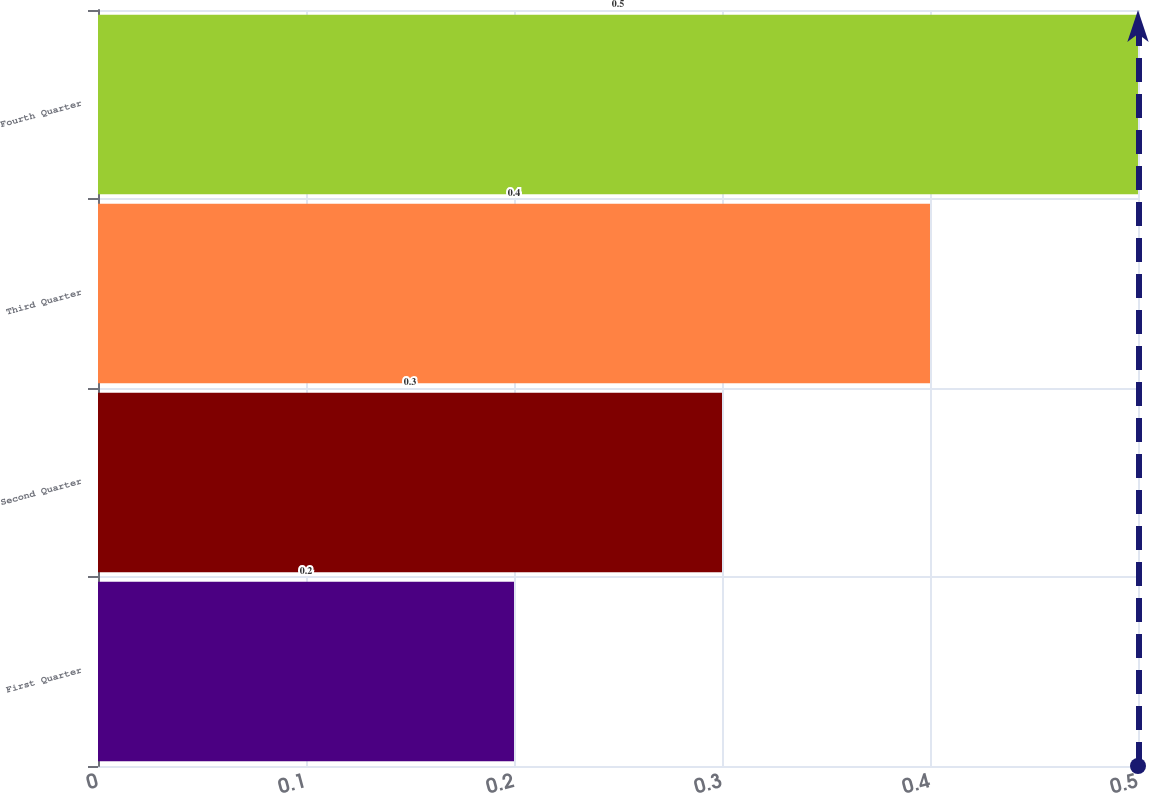Convert chart to OTSL. <chart><loc_0><loc_0><loc_500><loc_500><bar_chart><fcel>First Quarter<fcel>Second Quarter<fcel>Third Quarter<fcel>Fourth Quarter<nl><fcel>0.2<fcel>0.3<fcel>0.4<fcel>0.5<nl></chart> 